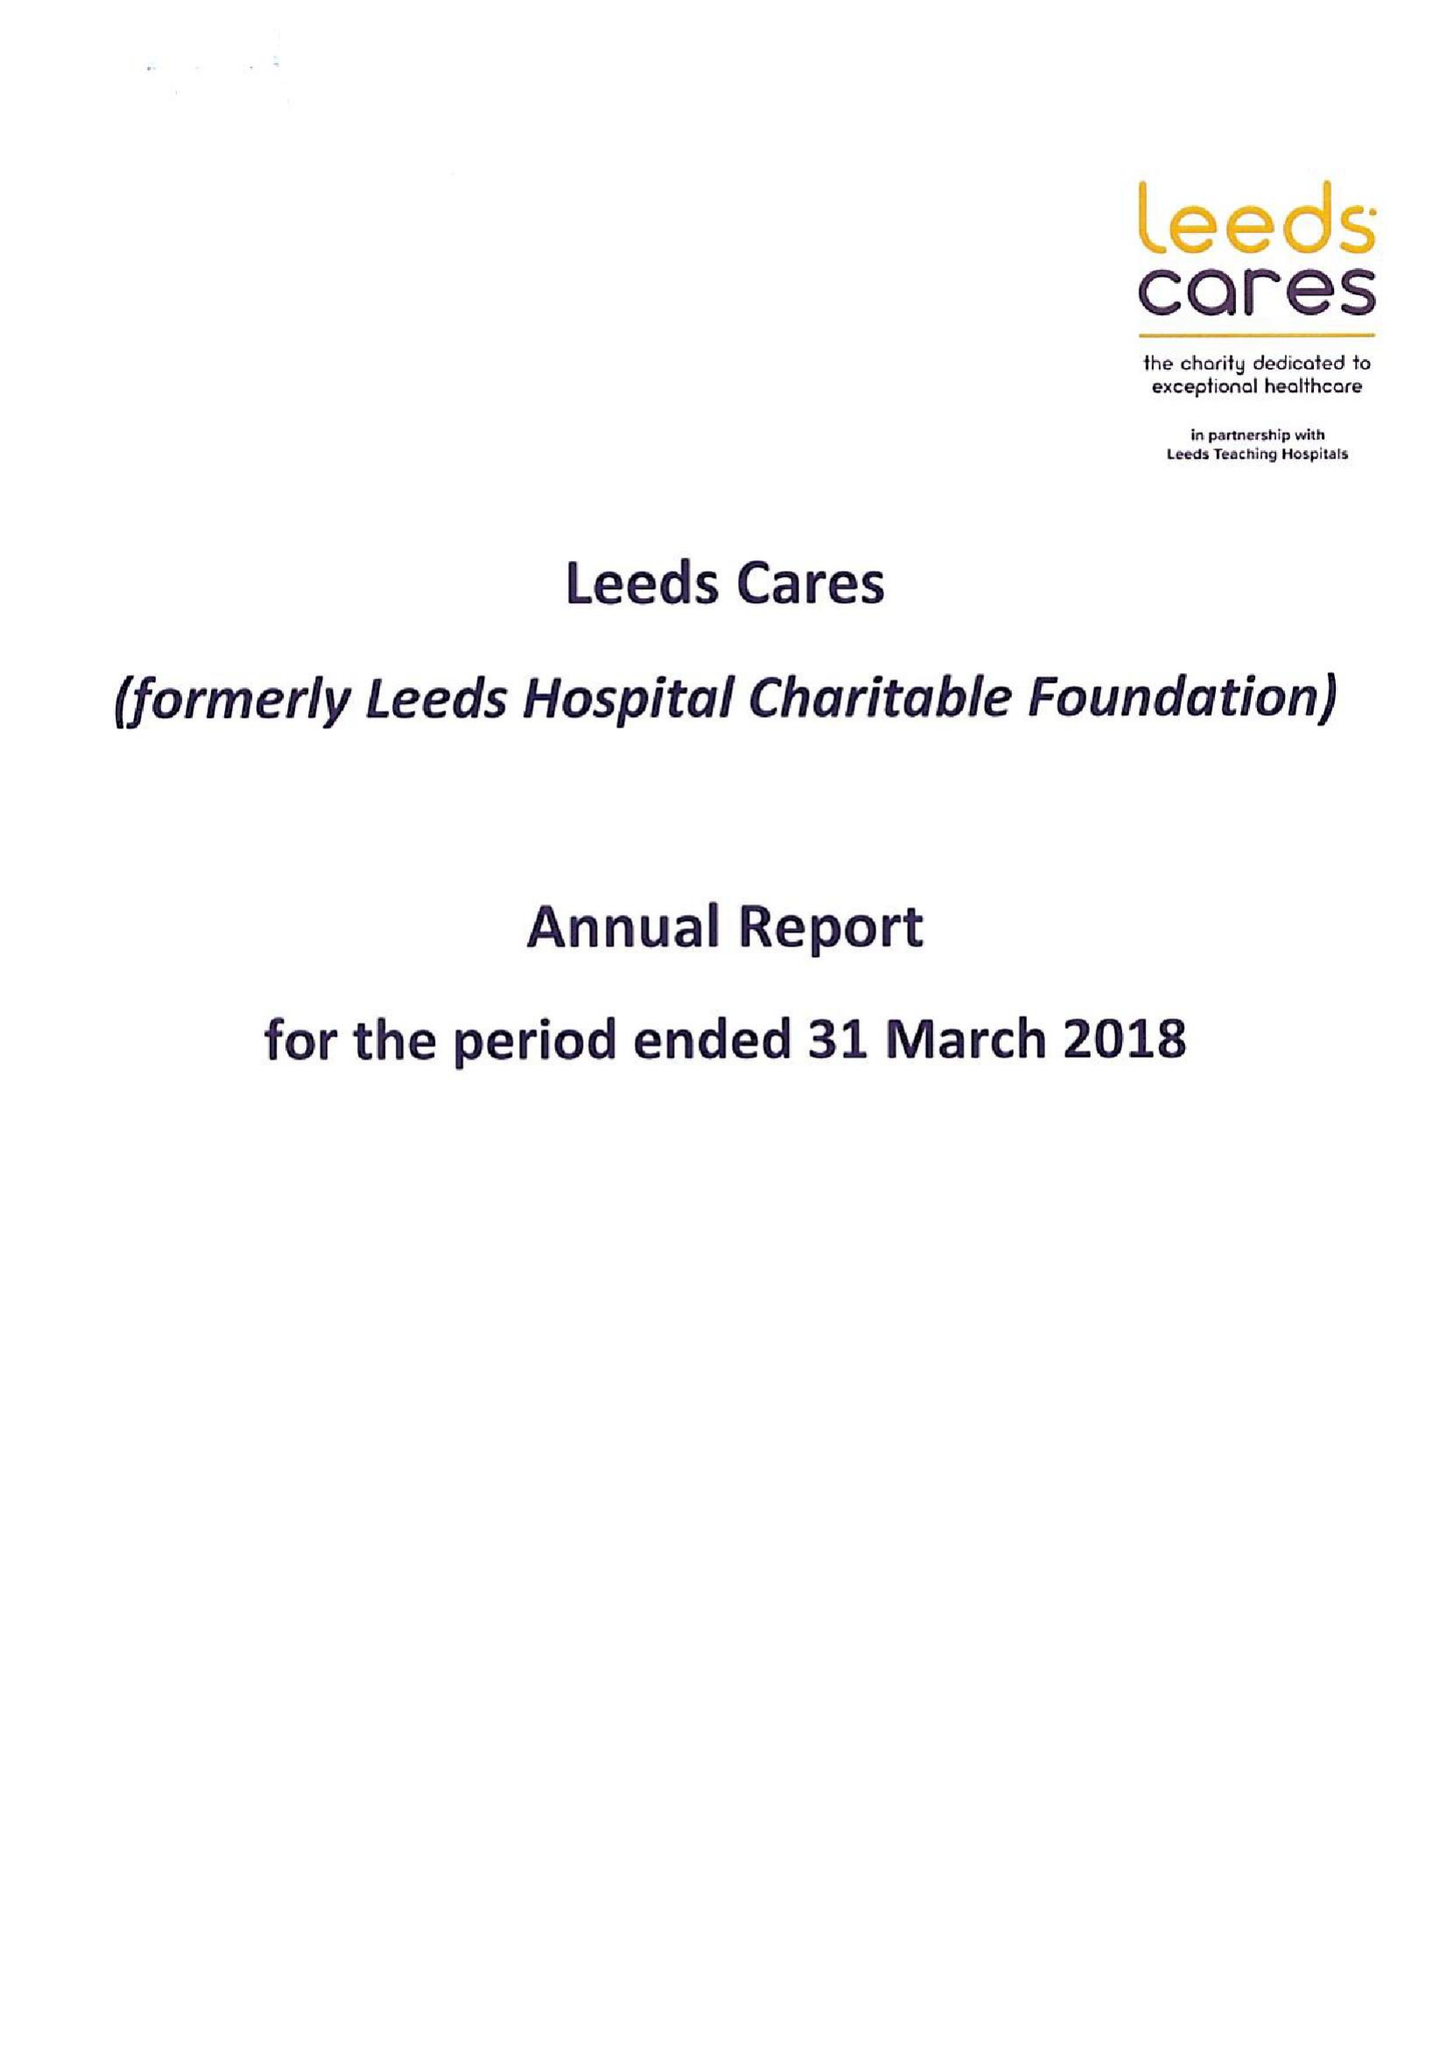What is the value for the income_annually_in_british_pounds?
Answer the question using a single word or phrase. 48027000.00 